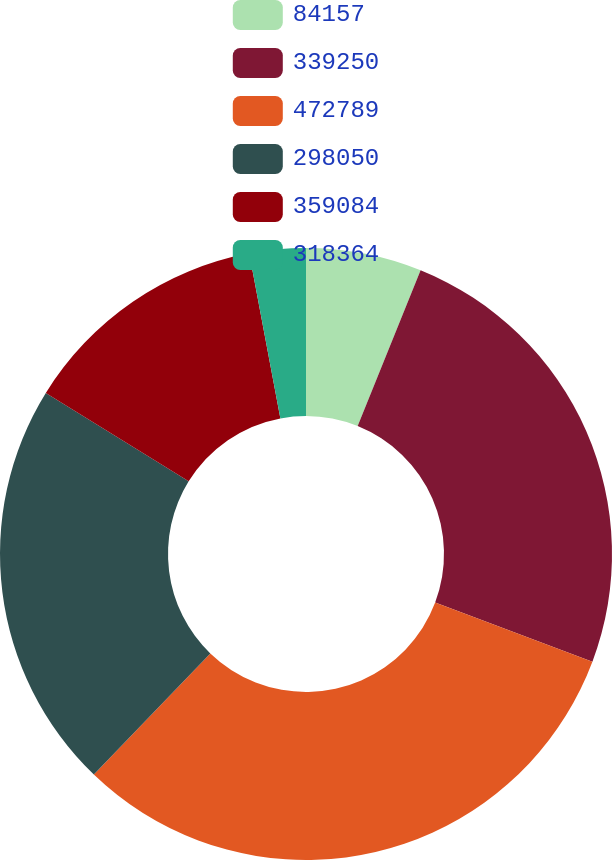Convert chart. <chart><loc_0><loc_0><loc_500><loc_500><pie_chart><fcel>84157<fcel>339250<fcel>472789<fcel>298050<fcel>359084<fcel>318364<nl><fcel>6.11%<fcel>24.62%<fcel>31.47%<fcel>21.63%<fcel>13.21%<fcel>2.97%<nl></chart> 